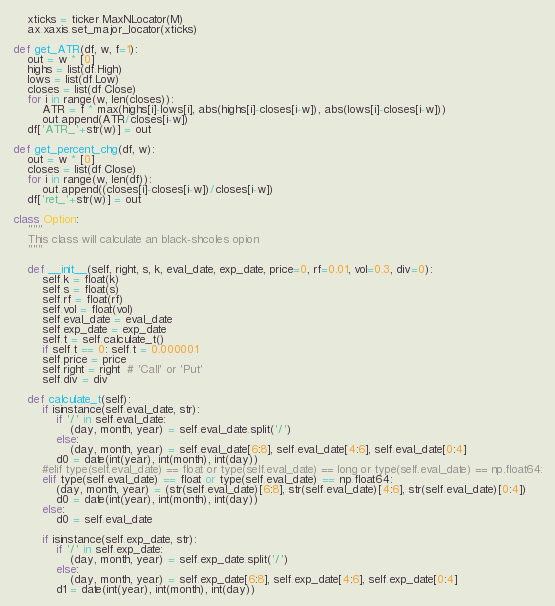Convert code to text. <code><loc_0><loc_0><loc_500><loc_500><_Python_>    xticks = ticker.MaxNLocator(M)
    ax.xaxis.set_major_locator(xticks)

def get_ATR(df, w, f=1):
    out = w * [0]
    highs = list(df.High)
    lows = list(df.Low)
    closes = list(df.Close)
    for i in range(w, len(closes)):
        ATR = f * max(highs[i]-lows[i], abs(highs[i]-closes[i-w]), abs(lows[i]-closes[i-w]))
        out.append(ATR/closes[i-w])
    df['ATR_'+str(w)] = out

def get_percent_chg(df, w):
    out = w * [0]
    closes = list(df.Close)
    for i in range(w, len(df)):
        out.append((closes[i]-closes[i-w])/closes[i-w])
    df['ret_'+str(w)] = out

class Option:
    """
    This class will calculate an black-shcoles opion
    """

    def __init__(self, right, s, k, eval_date, exp_date, price=0, rf=0.01, vol=0.3, div=0):
        self.k = float(k)
        self.s = float(s)
        self.rf = float(rf)
        self.vol = float(vol)
        self.eval_date = eval_date
        self.exp_date = exp_date
        self.t = self.calculate_t()
        if self.t == 0: self.t = 0.000001
        self.price = price
        self.right = right  # 'Call' or 'Put'
        self.div = div

    def calculate_t(self):
        if isinstance(self.eval_date, str):
            if '/' in self.eval_date:
                (day, month, year) = self.eval_date.split('/')
            else:
                (day, month, year) = self.eval_date[6:8], self.eval_date[4:6], self.eval_date[0:4]
            d0 = date(int(year), int(month), int(day))
        #elif type(self.eval_date) == float or type(self.eval_date) == long or type(self.eval_date) == np.float64:
        elif type(self.eval_date) == float or type(self.eval_date) == np.float64:
            (day, month, year) = (str(self.eval_date)[6:8], str(self.eval_date)[4:6], str(self.eval_date)[0:4])
            d0 = date(int(year), int(month), int(day))
        else:
            d0 = self.eval_date

        if isinstance(self.exp_date, str):
            if '/' in self.exp_date:
                (day, month, year) = self.exp_date.split('/')
            else:
                (day, month, year) = self.exp_date[6:8], self.exp_date[4:6], self.exp_date[0:4]
            d1 = date(int(year), int(month), int(day))</code> 